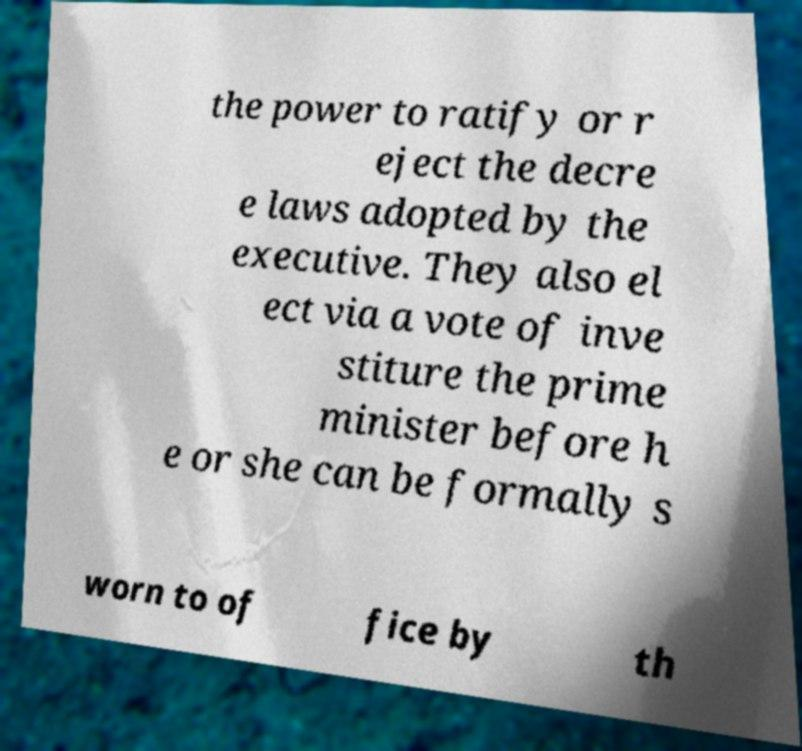There's text embedded in this image that I need extracted. Can you transcribe it verbatim? the power to ratify or r eject the decre e laws adopted by the executive. They also el ect via a vote of inve stiture the prime minister before h e or she can be formally s worn to of fice by th 